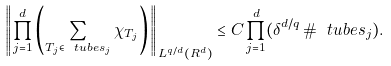<formula> <loc_0><loc_0><loc_500><loc_500>\left \| \prod _ { j = 1 } ^ { d } \left ( \sum _ { T _ { j } \in \ t u b e s _ { j } } \chi _ { T _ { j } } \right ) \right \| _ { L ^ { q / d } ( { R } ^ { d } ) } \leq C \prod _ { j = 1 } ^ { d } ( \delta ^ { d / q } \, \# \ t u b e s _ { j } ) .</formula> 